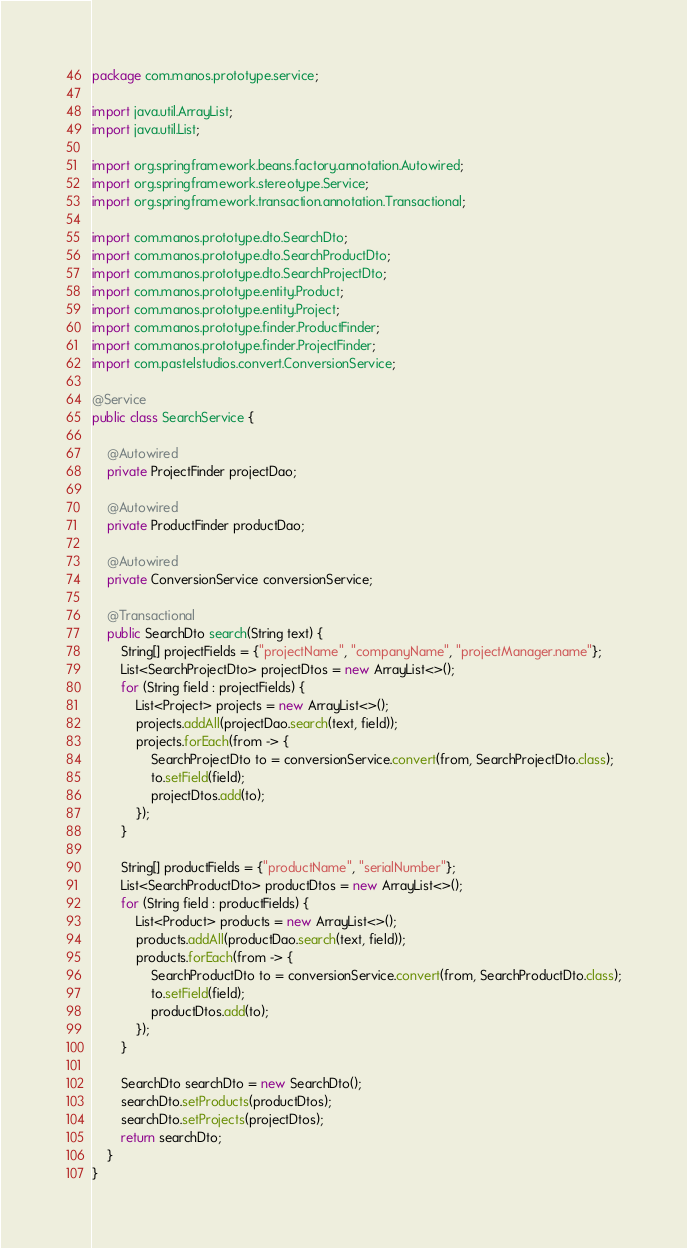<code> <loc_0><loc_0><loc_500><loc_500><_Java_>package com.manos.prototype.service;

import java.util.ArrayList;
import java.util.List;

import org.springframework.beans.factory.annotation.Autowired;
import org.springframework.stereotype.Service;
import org.springframework.transaction.annotation.Transactional;

import com.manos.prototype.dto.SearchDto;
import com.manos.prototype.dto.SearchProductDto;
import com.manos.prototype.dto.SearchProjectDto;
import com.manos.prototype.entity.Product;
import com.manos.prototype.entity.Project;
import com.manos.prototype.finder.ProductFinder;
import com.manos.prototype.finder.ProjectFinder;
import com.pastelstudios.convert.ConversionService;

@Service
public class SearchService {
	
	@Autowired
	private ProjectFinder projectDao;

	@Autowired
	private ProductFinder productDao;
	
	@Autowired
	private ConversionService conversionService;

	@Transactional
	public SearchDto search(String text) {
		String[] projectFields = {"projectName", "companyName", "projectManager.name"};
		List<SearchProjectDto> projectDtos = new ArrayList<>();
		for (String field : projectFields) {
			List<Project> projects = new ArrayList<>();
			projects.addAll(projectDao.search(text, field));
			projects.forEach(from -> {
				SearchProjectDto to = conversionService.convert(from, SearchProjectDto.class);
				to.setField(field);
				projectDtos.add(to);
			});
		}
		
		String[] productFields = {"productName", "serialNumber"};
		List<SearchProductDto> productDtos = new ArrayList<>();
		for (String field : productFields) {
			List<Product> products = new ArrayList<>();
			products.addAll(productDao.search(text, field));
			products.forEach(from -> {
				SearchProductDto to = conversionService.convert(from, SearchProductDto.class);
				to.setField(field);
				productDtos.add(to);
			});
		}
		
		SearchDto searchDto = new SearchDto();
		searchDto.setProducts(productDtos);
		searchDto.setProjects(projectDtos);
		return searchDto;
	}
}
</code> 